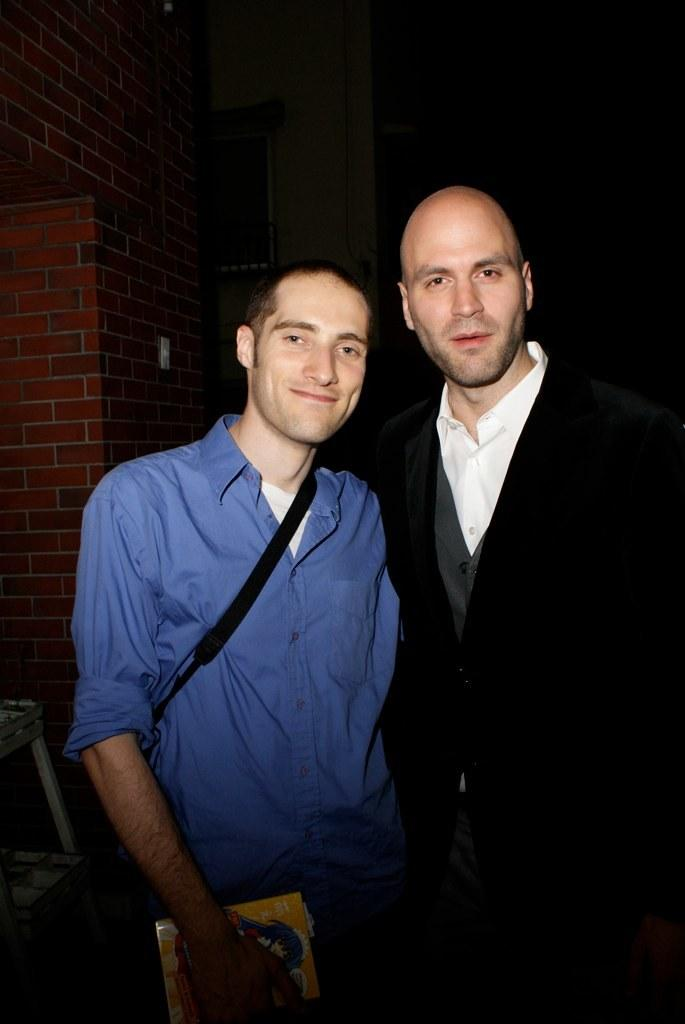How many people are in the image? There are two people standing in the center of the image. What can be seen in the background of the image? There is a wall in the background of the image. How many pies are being held by the cows in the image? There are no cows or pies present in the image. Can you describe the bat that is flying in the image? There is no bat present in the image. 